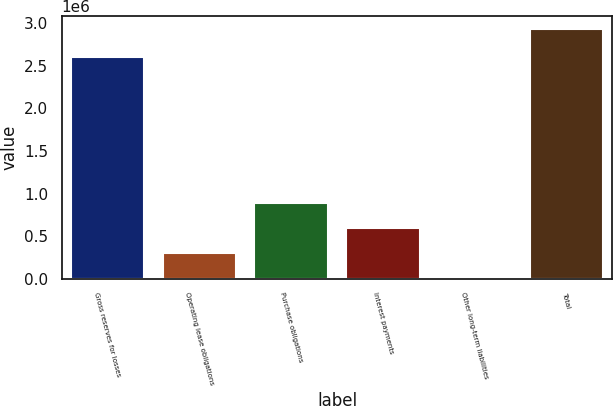Convert chart to OTSL. <chart><loc_0><loc_0><loc_500><loc_500><bar_chart><fcel>Gross reserves for losses<fcel>Operating lease obligations<fcel>Purchase obligations<fcel>Interest payments<fcel>Other long-term liabilities<fcel>Total<nl><fcel>2.60211e+06<fcel>302912<fcel>888182<fcel>595547<fcel>10277<fcel>2.93663e+06<nl></chart> 